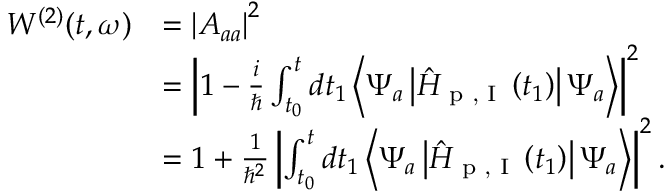<formula> <loc_0><loc_0><loc_500><loc_500>\begin{array} { r l } { W ^ { ( 2 ) } ( t , \omega ) } & { = \left | A _ { a a } \right | ^ { 2 } } \\ & { = \left | 1 - \frac { i } { } \int _ { t _ { 0 } } ^ { t } d t _ { 1 } \left \langle \Psi _ { a } \left | \hat { H } _ { p , I } \left ( t _ { 1 } \right ) \right | \Psi _ { a } \right \rangle \right | ^ { 2 } } \\ & { = 1 + \frac { 1 } { \hbar { ^ } { 2 } } \left | \int _ { t _ { 0 } } ^ { t } d t _ { 1 } \left \langle \Psi _ { a } \left | \hat { H } _ { p , I } \left ( t _ { 1 } \right ) \right | \Psi _ { a } \right \rangle \right | ^ { 2 } . } \end{array}</formula> 